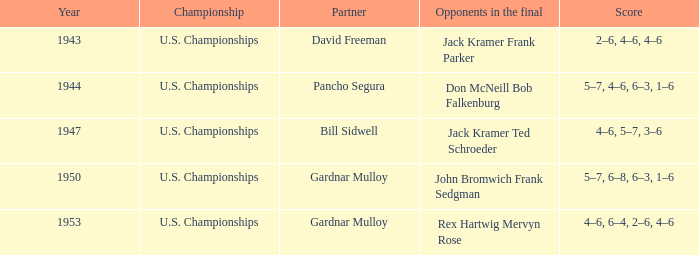In the final match between john bromwich and frank sedgman, what were the scores for their opponents? 5–7, 6–8, 6–3, 1–6. 